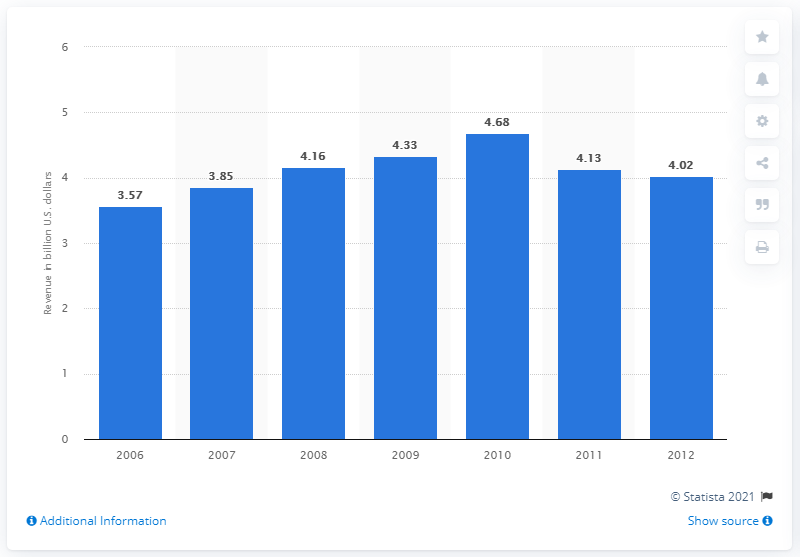Give some essential details in this illustration. The Washington Post Company's revenue a year earlier was 4.13 billion. 